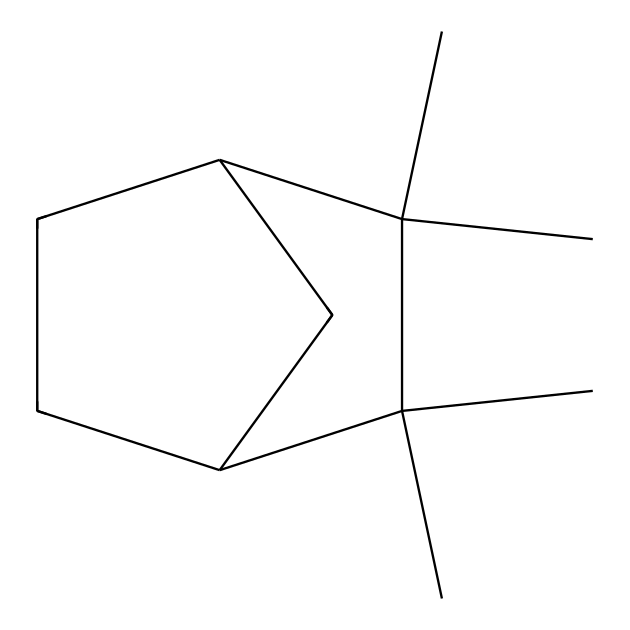How many carbon atoms are present in camphene? To determine the number of carbon atoms in camphene, we look at the SMILES representation. Each "C" in the structure indicates a carbon atom. Counting the "C" symbols, there are a total of 10 carbon atoms in the chemical structure.
Answer: 10 What is the molecular formula of camphene? The molecular formula can be derived from counting the numbers of carbon (C) and hydrogen (H) atoms in the structure. Since there are 10 carbon atoms and 16 hydrogen atoms based on the arrangement of the bonds, the molecular formula is C10H16.
Answer: C10H16 Is camphene a cyclic compound? The structure shows a ring formation (due to the presence of cycles in the molecular structure). This confirms that camphene is indeed a cyclic compound.
Answer: Yes How many double bonds are present in camphene? By analyzing the structure, we can see that there are no double bonds represented between any carbon atoms in the SMILES. Hence, camphene contains zero double bonds.
Answer: 0 What type of compound is camphene classified as? Camphene has a distinct structure characterized as a terpene, which is recognized by the arrangement of carbon atoms and is derived from plant sources. Thus, camphene is classified as a terpene.
Answer: terpene Which part of the structure indicates it's a bicyclic compound? In the SMILES representation, the presence of two interconnected rings can be observed, showing that the compound has a dual cyclic structure. Therefore, camphene is indicated to be bicyclic.
Answer: bicyclic 